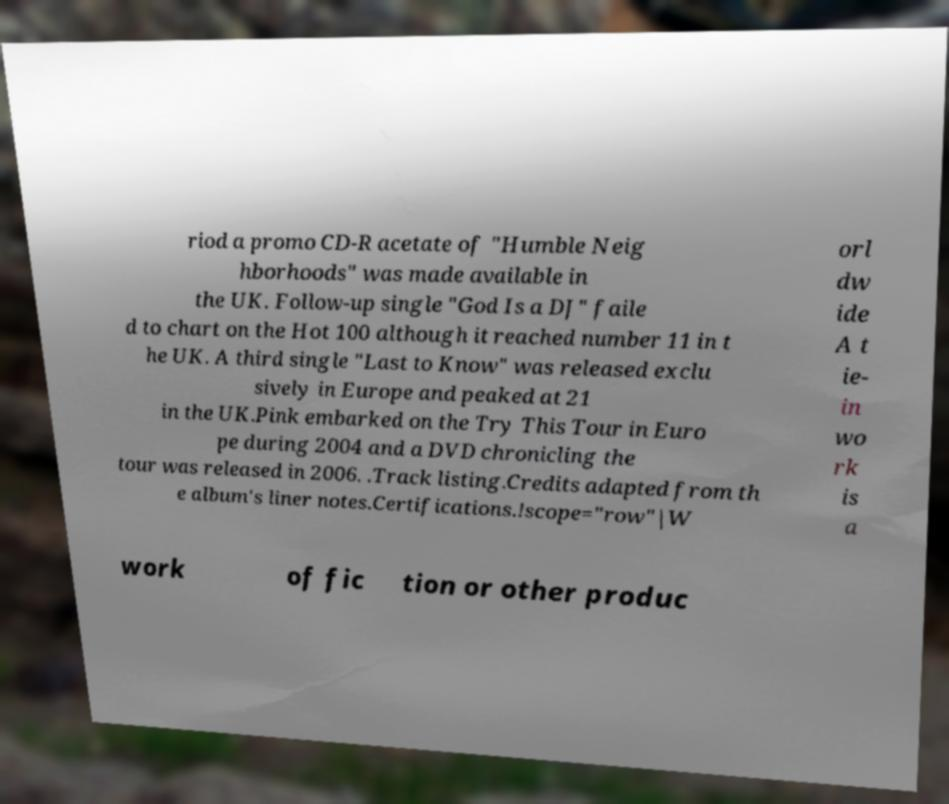There's text embedded in this image that I need extracted. Can you transcribe it verbatim? riod a promo CD-R acetate of "Humble Neig hborhoods" was made available in the UK. Follow-up single "God Is a DJ" faile d to chart on the Hot 100 although it reached number 11 in t he UK. A third single "Last to Know" was released exclu sively in Europe and peaked at 21 in the UK.Pink embarked on the Try This Tour in Euro pe during 2004 and a DVD chronicling the tour was released in 2006. .Track listing.Credits adapted from th e album's liner notes.Certifications.!scope="row"|W orl dw ide A t ie- in wo rk is a work of fic tion or other produc 